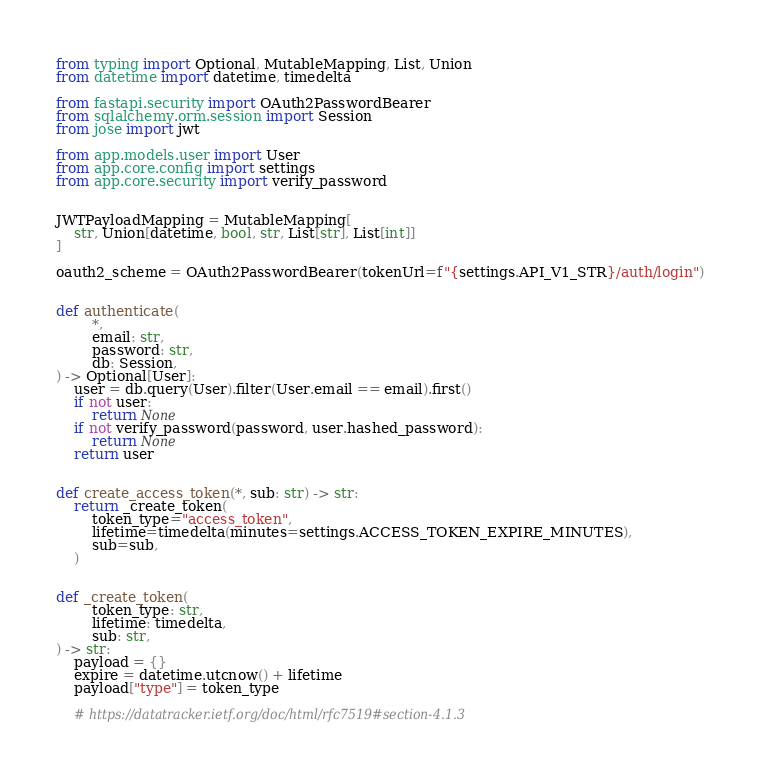<code> <loc_0><loc_0><loc_500><loc_500><_Python_>from typing import Optional, MutableMapping, List, Union
from datetime import datetime, timedelta

from fastapi.security import OAuth2PasswordBearer
from sqlalchemy.orm.session import Session
from jose import jwt

from app.models.user import User
from app.core.config import settings
from app.core.security import verify_password


JWTPayloadMapping = MutableMapping[
    str, Union[datetime, bool, str, List[str], List[int]]
]

oauth2_scheme = OAuth2PasswordBearer(tokenUrl=f"{settings.API_V1_STR}/auth/login")


def authenticate(
        *,
        email: str,
        password: str,
        db: Session,
) -> Optional[User]:
    user = db.query(User).filter(User.email == email).first()
    if not user:
        return None
    if not verify_password(password, user.hashed_password):
        return None
    return user


def create_access_token(*, sub: str) -> str:
    return _create_token(
        token_type="access_token",
        lifetime=timedelta(minutes=settings.ACCESS_TOKEN_EXPIRE_MINUTES),
        sub=sub,
    )


def _create_token(
        token_type: str,
        lifetime: timedelta,
        sub: str,
) -> str:
    payload = {}
    expire = datetime.utcnow() + lifetime
    payload["type"] = token_type

    # https://datatracker.ietf.org/doc/html/rfc7519#section-4.1.3</code> 